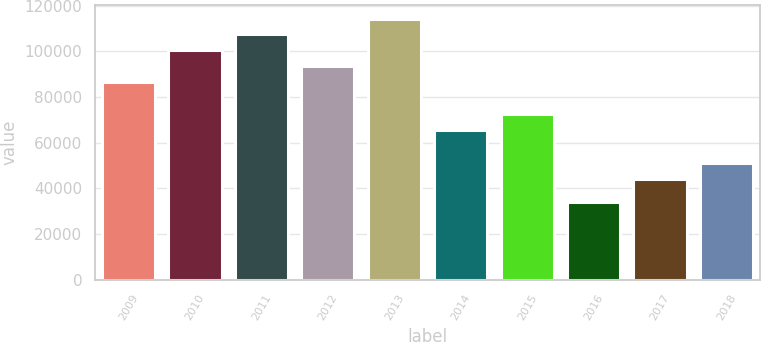Convert chart. <chart><loc_0><loc_0><loc_500><loc_500><bar_chart><fcel>2009<fcel>2010<fcel>2011<fcel>2012<fcel>2013<fcel>2014<fcel>2015<fcel>2016<fcel>2017<fcel>2018<nl><fcel>86454.1<fcel>100422<fcel>107405<fcel>93437.8<fcel>114389<fcel>65503<fcel>72486.7<fcel>33825<fcel>44010<fcel>50993.7<nl></chart> 